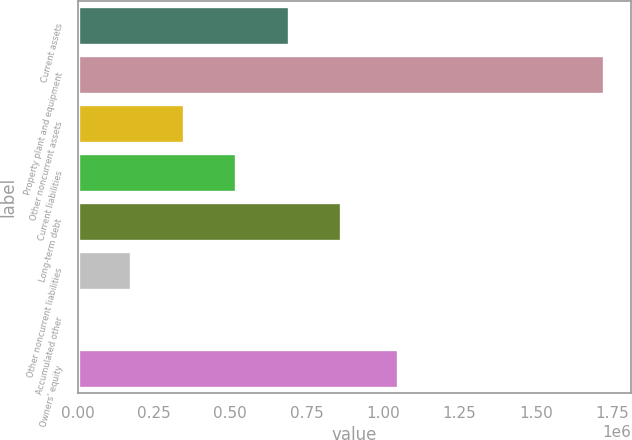<chart> <loc_0><loc_0><loc_500><loc_500><bar_chart><fcel>Current assets<fcel>Property plant and equipment<fcel>Other noncurrent assets<fcel>Current liabilities<fcel>Long-term debt<fcel>Other noncurrent liabilities<fcel>Accumulated other<fcel>Owners' equity<nl><fcel>691197<fcel>1.72433e+06<fcel>346819<fcel>519008<fcel>863386<fcel>174630<fcel>2441<fcel>1.04829e+06<nl></chart> 